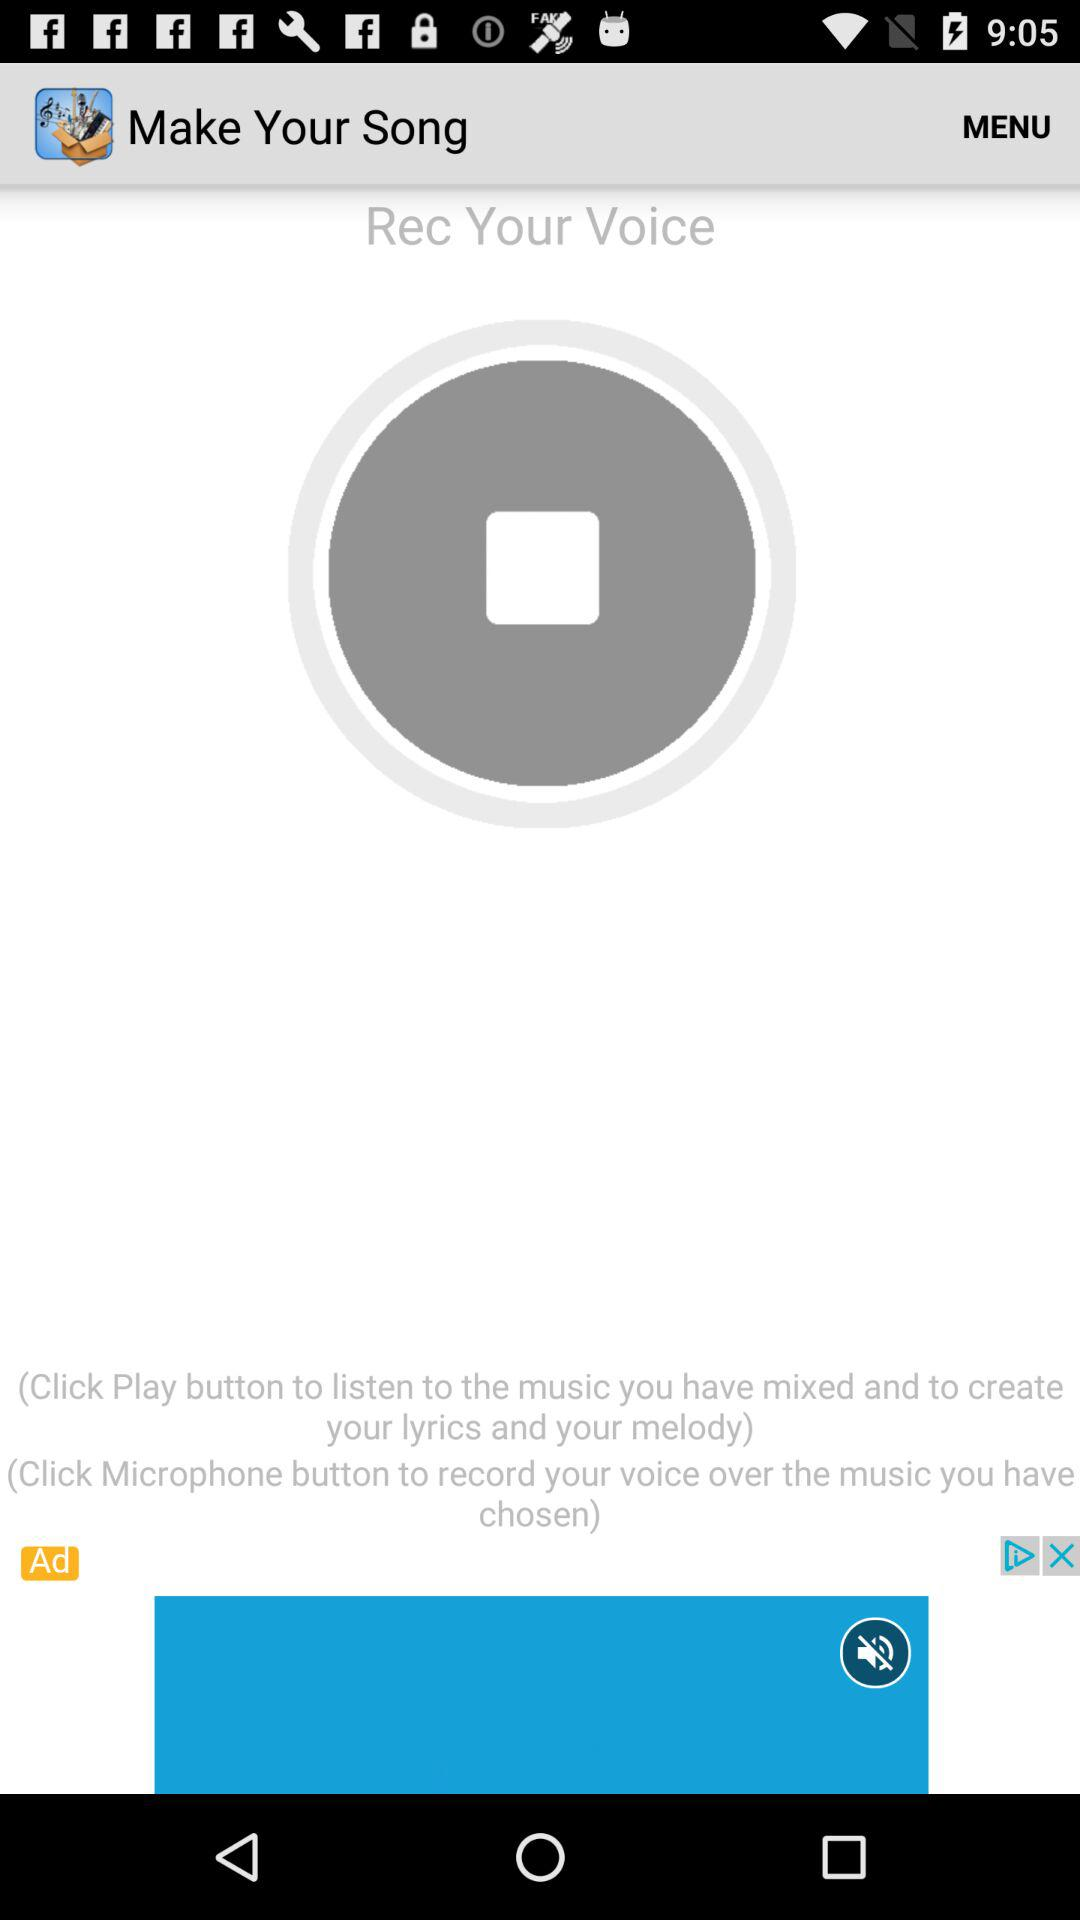What is the name of the application? The name of the application is "Make Your Song". 